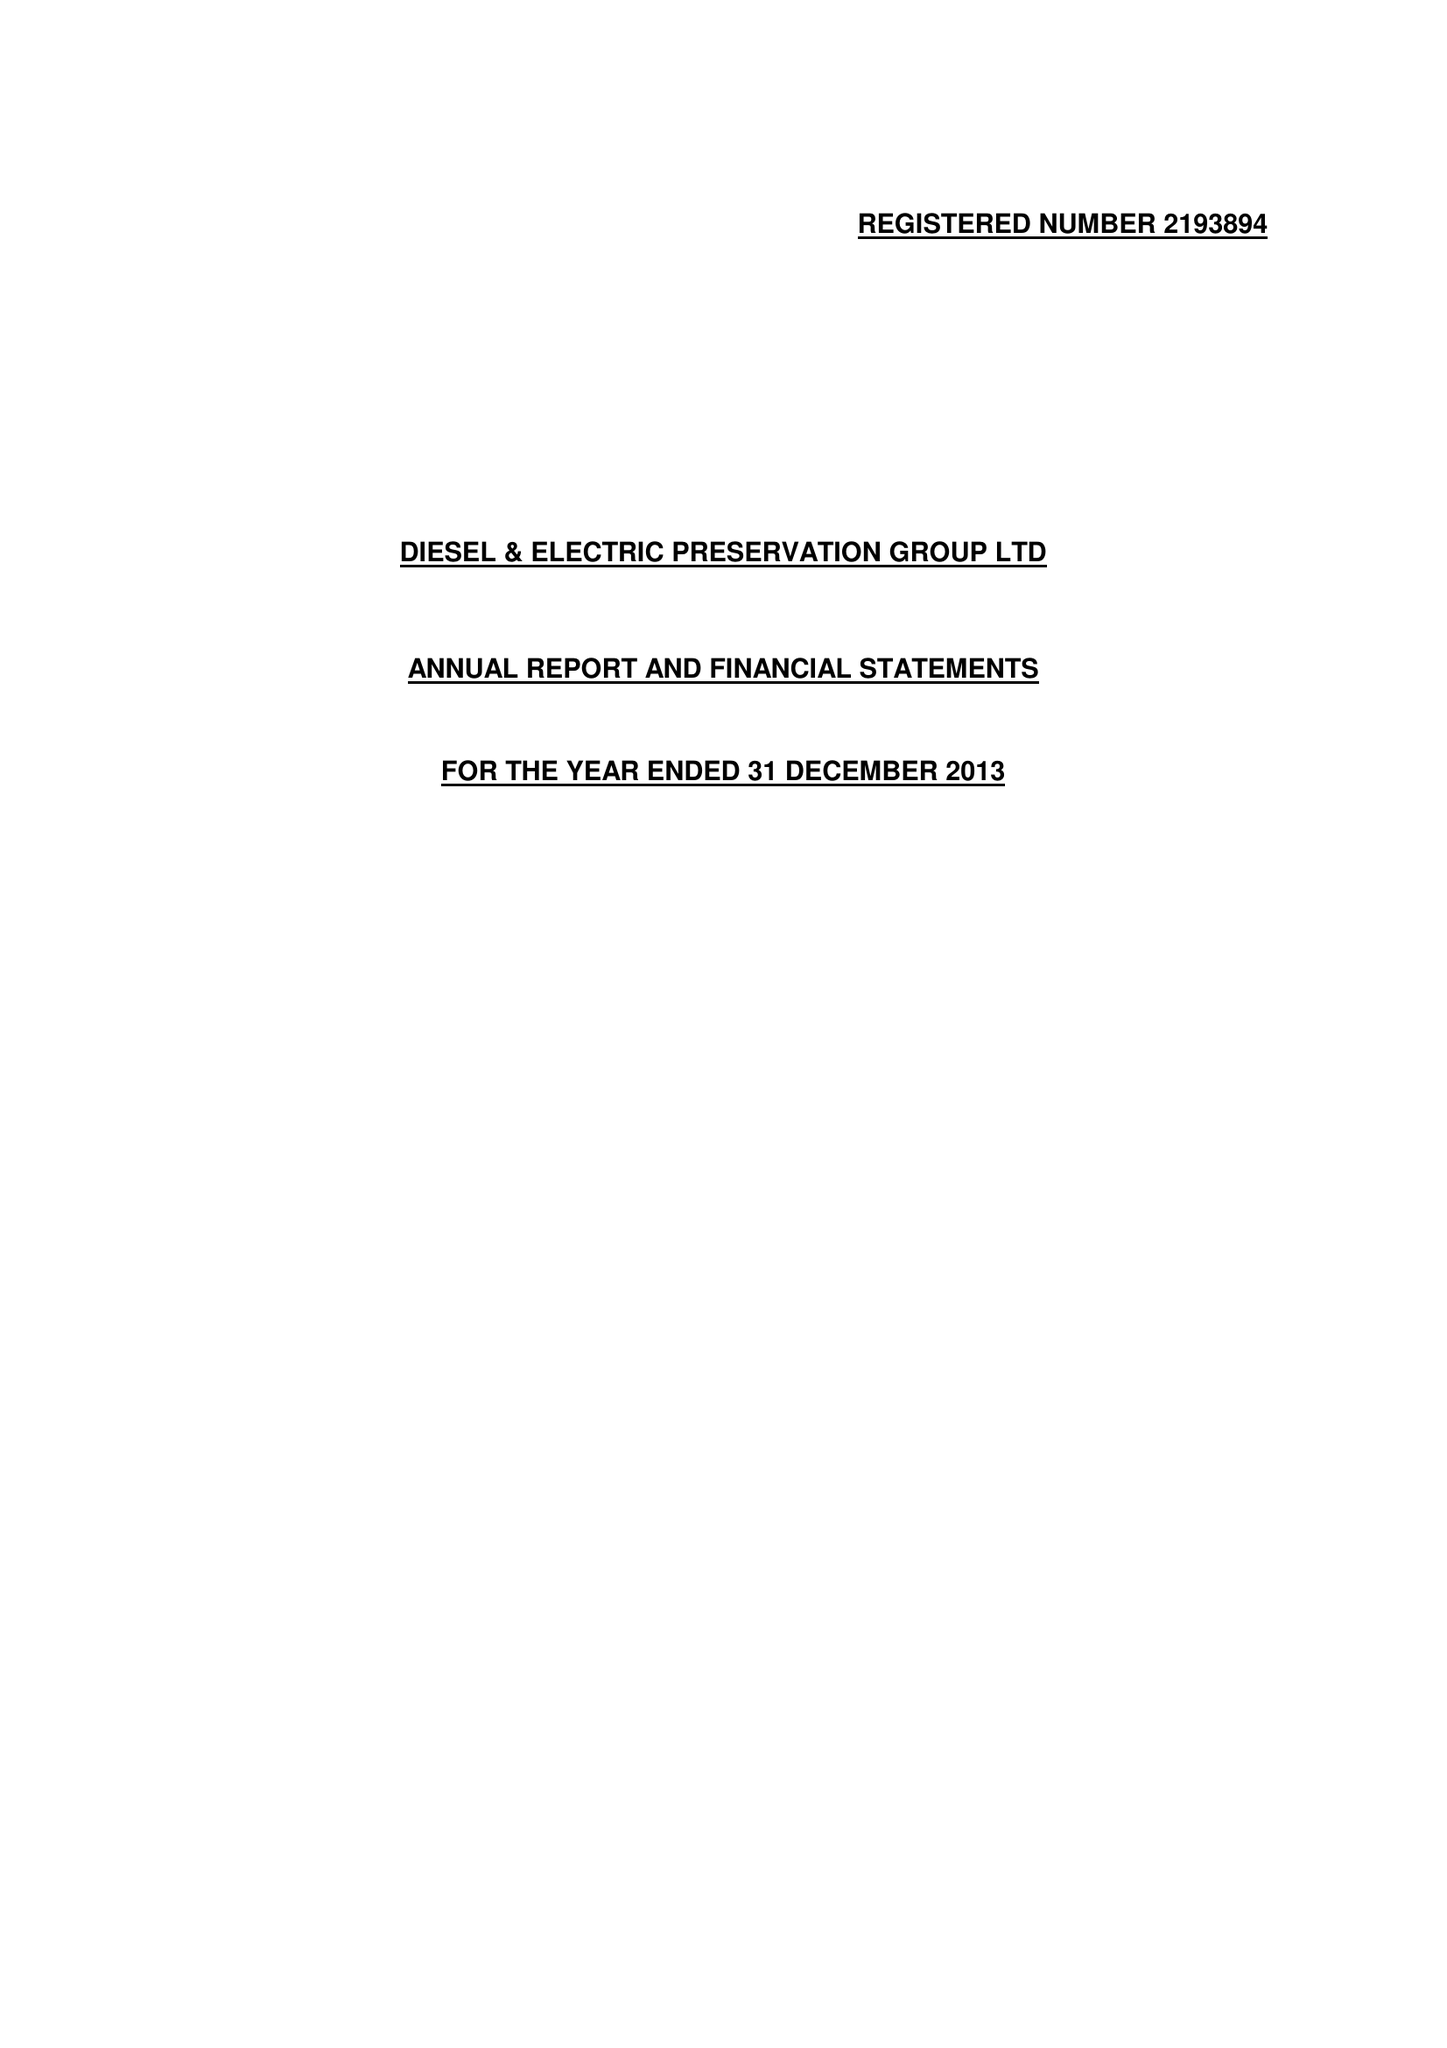What is the value for the spending_annually_in_british_pounds?
Answer the question using a single word or phrase. 50978.00 